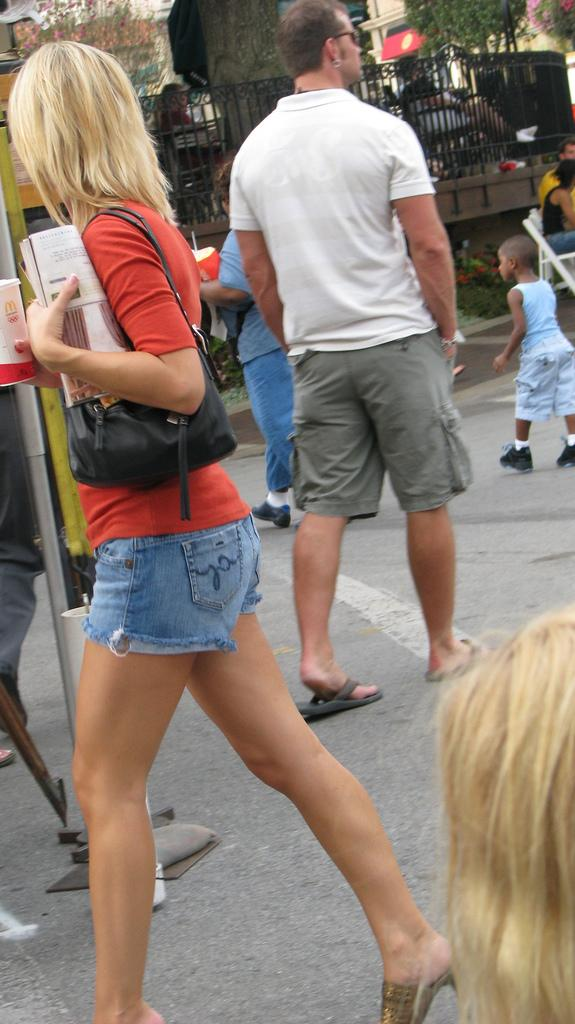What are the people in the image doing? There are persons walking on the road in the image. What can be seen in the background of the image? There is a fence, trees, and buildings in the background of the image. What type of insurance policy do the trees in the image offer? There is no mention of insurance in the image, and the trees are not offering any policies. 